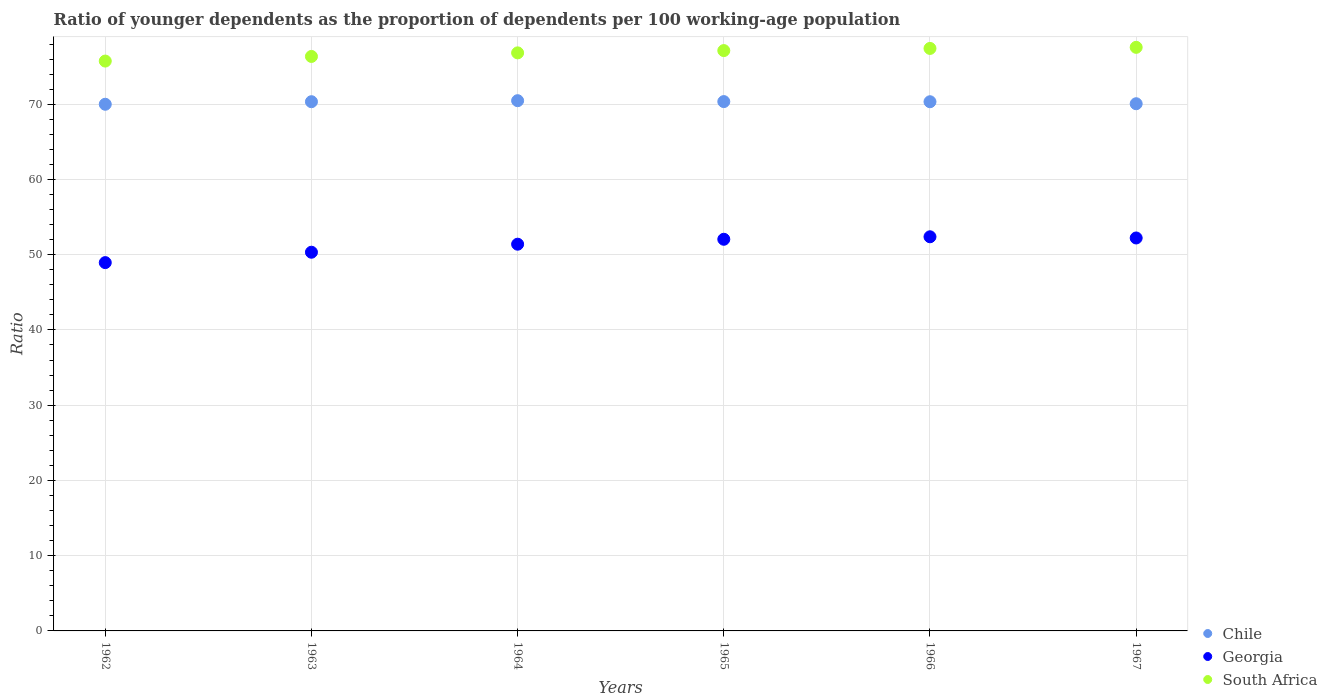Is the number of dotlines equal to the number of legend labels?
Provide a succinct answer. Yes. What is the age dependency ratio(young) in Chile in 1967?
Offer a very short reply. 70.06. Across all years, what is the maximum age dependency ratio(young) in Georgia?
Give a very brief answer. 52.38. Across all years, what is the minimum age dependency ratio(young) in South Africa?
Make the answer very short. 75.73. In which year was the age dependency ratio(young) in Georgia maximum?
Provide a short and direct response. 1966. In which year was the age dependency ratio(young) in Chile minimum?
Your answer should be very brief. 1962. What is the total age dependency ratio(young) in Georgia in the graph?
Ensure brevity in your answer.  307.33. What is the difference between the age dependency ratio(young) in South Africa in 1963 and that in 1966?
Offer a very short reply. -1.07. What is the difference between the age dependency ratio(young) in South Africa in 1963 and the age dependency ratio(young) in Georgia in 1964?
Your answer should be compact. 24.95. What is the average age dependency ratio(young) in Georgia per year?
Your answer should be very brief. 51.22. In the year 1965, what is the difference between the age dependency ratio(young) in South Africa and age dependency ratio(young) in Georgia?
Provide a succinct answer. 25.08. What is the ratio of the age dependency ratio(young) in Chile in 1962 to that in 1963?
Your answer should be very brief. 1. Is the age dependency ratio(young) in South Africa in 1962 less than that in 1964?
Your response must be concise. Yes. What is the difference between the highest and the second highest age dependency ratio(young) in South Africa?
Keep it short and to the point. 0.14. What is the difference between the highest and the lowest age dependency ratio(young) in South Africa?
Keep it short and to the point. 1.82. In how many years, is the age dependency ratio(young) in Chile greater than the average age dependency ratio(young) in Chile taken over all years?
Your answer should be compact. 4. Is it the case that in every year, the sum of the age dependency ratio(young) in Georgia and age dependency ratio(young) in South Africa  is greater than the age dependency ratio(young) in Chile?
Provide a succinct answer. Yes. Is the age dependency ratio(young) in South Africa strictly less than the age dependency ratio(young) in Georgia over the years?
Your answer should be very brief. No. How many dotlines are there?
Keep it short and to the point. 3. How many years are there in the graph?
Your response must be concise. 6. Does the graph contain any zero values?
Offer a terse response. No. Does the graph contain grids?
Provide a short and direct response. Yes. How are the legend labels stacked?
Provide a short and direct response. Vertical. What is the title of the graph?
Make the answer very short. Ratio of younger dependents as the proportion of dependents per 100 working-age population. Does "Chile" appear as one of the legend labels in the graph?
Offer a terse response. Yes. What is the label or title of the Y-axis?
Give a very brief answer. Ratio. What is the Ratio of Chile in 1962?
Offer a terse response. 69.99. What is the Ratio in Georgia in 1962?
Provide a short and direct response. 48.95. What is the Ratio of South Africa in 1962?
Offer a terse response. 75.73. What is the Ratio in Chile in 1963?
Provide a short and direct response. 70.33. What is the Ratio of Georgia in 1963?
Ensure brevity in your answer.  50.33. What is the Ratio in South Africa in 1963?
Your answer should be very brief. 76.35. What is the Ratio of Chile in 1964?
Your answer should be compact. 70.47. What is the Ratio in Georgia in 1964?
Your answer should be very brief. 51.4. What is the Ratio of South Africa in 1964?
Provide a succinct answer. 76.82. What is the Ratio of Chile in 1965?
Ensure brevity in your answer.  70.35. What is the Ratio of Georgia in 1965?
Provide a short and direct response. 52.05. What is the Ratio in South Africa in 1965?
Offer a very short reply. 77.13. What is the Ratio in Chile in 1966?
Ensure brevity in your answer.  70.33. What is the Ratio in Georgia in 1966?
Keep it short and to the point. 52.38. What is the Ratio of South Africa in 1966?
Provide a short and direct response. 77.41. What is the Ratio of Chile in 1967?
Your answer should be very brief. 70.06. What is the Ratio in Georgia in 1967?
Ensure brevity in your answer.  52.22. What is the Ratio in South Africa in 1967?
Offer a terse response. 77.56. Across all years, what is the maximum Ratio in Chile?
Your answer should be compact. 70.47. Across all years, what is the maximum Ratio of Georgia?
Your response must be concise. 52.38. Across all years, what is the maximum Ratio of South Africa?
Provide a succinct answer. 77.56. Across all years, what is the minimum Ratio of Chile?
Your response must be concise. 69.99. Across all years, what is the minimum Ratio of Georgia?
Keep it short and to the point. 48.95. Across all years, what is the minimum Ratio in South Africa?
Ensure brevity in your answer.  75.73. What is the total Ratio of Chile in the graph?
Ensure brevity in your answer.  421.53. What is the total Ratio in Georgia in the graph?
Provide a succinct answer. 307.33. What is the total Ratio of South Africa in the graph?
Provide a succinct answer. 461. What is the difference between the Ratio of Chile in 1962 and that in 1963?
Your answer should be very brief. -0.34. What is the difference between the Ratio in Georgia in 1962 and that in 1963?
Your answer should be compact. -1.38. What is the difference between the Ratio of South Africa in 1962 and that in 1963?
Offer a very short reply. -0.61. What is the difference between the Ratio of Chile in 1962 and that in 1964?
Ensure brevity in your answer.  -0.47. What is the difference between the Ratio of Georgia in 1962 and that in 1964?
Give a very brief answer. -2.45. What is the difference between the Ratio of South Africa in 1962 and that in 1964?
Provide a short and direct response. -1.09. What is the difference between the Ratio in Chile in 1962 and that in 1965?
Make the answer very short. -0.36. What is the difference between the Ratio in Georgia in 1962 and that in 1965?
Your answer should be compact. -3.1. What is the difference between the Ratio in South Africa in 1962 and that in 1965?
Provide a succinct answer. -1.39. What is the difference between the Ratio of Chile in 1962 and that in 1966?
Make the answer very short. -0.34. What is the difference between the Ratio in Georgia in 1962 and that in 1966?
Give a very brief answer. -3.43. What is the difference between the Ratio of South Africa in 1962 and that in 1966?
Your answer should be very brief. -1.68. What is the difference between the Ratio of Chile in 1962 and that in 1967?
Your answer should be compact. -0.07. What is the difference between the Ratio in Georgia in 1962 and that in 1967?
Your answer should be compact. -3.27. What is the difference between the Ratio of South Africa in 1962 and that in 1967?
Offer a very short reply. -1.82. What is the difference between the Ratio in Chile in 1963 and that in 1964?
Offer a terse response. -0.14. What is the difference between the Ratio in Georgia in 1963 and that in 1964?
Provide a short and direct response. -1.07. What is the difference between the Ratio of South Africa in 1963 and that in 1964?
Keep it short and to the point. -0.48. What is the difference between the Ratio in Chile in 1963 and that in 1965?
Offer a very short reply. -0.02. What is the difference between the Ratio in Georgia in 1963 and that in 1965?
Keep it short and to the point. -1.72. What is the difference between the Ratio in South Africa in 1963 and that in 1965?
Your response must be concise. -0.78. What is the difference between the Ratio in Chile in 1963 and that in 1966?
Give a very brief answer. 0. What is the difference between the Ratio of Georgia in 1963 and that in 1966?
Your answer should be compact. -2.05. What is the difference between the Ratio in South Africa in 1963 and that in 1966?
Give a very brief answer. -1.07. What is the difference between the Ratio in Chile in 1963 and that in 1967?
Provide a succinct answer. 0.27. What is the difference between the Ratio of Georgia in 1963 and that in 1967?
Provide a short and direct response. -1.89. What is the difference between the Ratio in South Africa in 1963 and that in 1967?
Provide a succinct answer. -1.21. What is the difference between the Ratio of Chile in 1964 and that in 1965?
Offer a terse response. 0.12. What is the difference between the Ratio of Georgia in 1964 and that in 1965?
Your answer should be compact. -0.66. What is the difference between the Ratio of South Africa in 1964 and that in 1965?
Provide a short and direct response. -0.3. What is the difference between the Ratio in Chile in 1964 and that in 1966?
Provide a short and direct response. 0.14. What is the difference between the Ratio of Georgia in 1964 and that in 1966?
Offer a very short reply. -0.99. What is the difference between the Ratio of South Africa in 1964 and that in 1966?
Your response must be concise. -0.59. What is the difference between the Ratio in Chile in 1964 and that in 1967?
Keep it short and to the point. 0.4. What is the difference between the Ratio of Georgia in 1964 and that in 1967?
Ensure brevity in your answer.  -0.83. What is the difference between the Ratio of South Africa in 1964 and that in 1967?
Your answer should be very brief. -0.73. What is the difference between the Ratio in Chile in 1965 and that in 1966?
Your answer should be compact. 0.02. What is the difference between the Ratio in Georgia in 1965 and that in 1966?
Provide a succinct answer. -0.33. What is the difference between the Ratio of South Africa in 1965 and that in 1966?
Make the answer very short. -0.29. What is the difference between the Ratio in Chile in 1965 and that in 1967?
Provide a short and direct response. 0.28. What is the difference between the Ratio of Georgia in 1965 and that in 1967?
Your answer should be very brief. -0.17. What is the difference between the Ratio in South Africa in 1965 and that in 1967?
Provide a short and direct response. -0.43. What is the difference between the Ratio in Chile in 1966 and that in 1967?
Keep it short and to the point. 0.27. What is the difference between the Ratio of Georgia in 1966 and that in 1967?
Offer a terse response. 0.16. What is the difference between the Ratio in South Africa in 1966 and that in 1967?
Provide a short and direct response. -0.14. What is the difference between the Ratio of Chile in 1962 and the Ratio of Georgia in 1963?
Provide a short and direct response. 19.66. What is the difference between the Ratio of Chile in 1962 and the Ratio of South Africa in 1963?
Your answer should be compact. -6.35. What is the difference between the Ratio of Georgia in 1962 and the Ratio of South Africa in 1963?
Your answer should be compact. -27.4. What is the difference between the Ratio of Chile in 1962 and the Ratio of Georgia in 1964?
Your response must be concise. 18.6. What is the difference between the Ratio of Chile in 1962 and the Ratio of South Africa in 1964?
Provide a succinct answer. -6.83. What is the difference between the Ratio of Georgia in 1962 and the Ratio of South Africa in 1964?
Provide a succinct answer. -27.88. What is the difference between the Ratio in Chile in 1962 and the Ratio in Georgia in 1965?
Make the answer very short. 17.94. What is the difference between the Ratio of Chile in 1962 and the Ratio of South Africa in 1965?
Keep it short and to the point. -7.13. What is the difference between the Ratio of Georgia in 1962 and the Ratio of South Africa in 1965?
Offer a very short reply. -28.18. What is the difference between the Ratio in Chile in 1962 and the Ratio in Georgia in 1966?
Provide a succinct answer. 17.61. What is the difference between the Ratio in Chile in 1962 and the Ratio in South Africa in 1966?
Provide a succinct answer. -7.42. What is the difference between the Ratio of Georgia in 1962 and the Ratio of South Africa in 1966?
Offer a terse response. -28.46. What is the difference between the Ratio in Chile in 1962 and the Ratio in Georgia in 1967?
Your response must be concise. 17.77. What is the difference between the Ratio in Chile in 1962 and the Ratio in South Africa in 1967?
Make the answer very short. -7.57. What is the difference between the Ratio in Georgia in 1962 and the Ratio in South Africa in 1967?
Offer a very short reply. -28.61. What is the difference between the Ratio of Chile in 1963 and the Ratio of Georgia in 1964?
Offer a very short reply. 18.94. What is the difference between the Ratio of Chile in 1963 and the Ratio of South Africa in 1964?
Provide a short and direct response. -6.49. What is the difference between the Ratio in Georgia in 1963 and the Ratio in South Africa in 1964?
Give a very brief answer. -26.5. What is the difference between the Ratio of Chile in 1963 and the Ratio of Georgia in 1965?
Offer a terse response. 18.28. What is the difference between the Ratio of Chile in 1963 and the Ratio of South Africa in 1965?
Give a very brief answer. -6.79. What is the difference between the Ratio in Georgia in 1963 and the Ratio in South Africa in 1965?
Make the answer very short. -26.8. What is the difference between the Ratio in Chile in 1963 and the Ratio in Georgia in 1966?
Provide a short and direct response. 17.95. What is the difference between the Ratio in Chile in 1963 and the Ratio in South Africa in 1966?
Make the answer very short. -7.08. What is the difference between the Ratio of Georgia in 1963 and the Ratio of South Africa in 1966?
Make the answer very short. -27.08. What is the difference between the Ratio of Chile in 1963 and the Ratio of Georgia in 1967?
Your response must be concise. 18.11. What is the difference between the Ratio of Chile in 1963 and the Ratio of South Africa in 1967?
Provide a succinct answer. -7.23. What is the difference between the Ratio in Georgia in 1963 and the Ratio in South Africa in 1967?
Give a very brief answer. -27.23. What is the difference between the Ratio in Chile in 1964 and the Ratio in Georgia in 1965?
Your answer should be very brief. 18.42. What is the difference between the Ratio in Chile in 1964 and the Ratio in South Africa in 1965?
Give a very brief answer. -6.66. What is the difference between the Ratio of Georgia in 1964 and the Ratio of South Africa in 1965?
Your response must be concise. -25.73. What is the difference between the Ratio of Chile in 1964 and the Ratio of Georgia in 1966?
Your answer should be compact. 18.09. What is the difference between the Ratio of Chile in 1964 and the Ratio of South Africa in 1966?
Provide a succinct answer. -6.95. What is the difference between the Ratio in Georgia in 1964 and the Ratio in South Africa in 1966?
Provide a short and direct response. -26.02. What is the difference between the Ratio in Chile in 1964 and the Ratio in Georgia in 1967?
Make the answer very short. 18.25. What is the difference between the Ratio in Chile in 1964 and the Ratio in South Africa in 1967?
Offer a terse response. -7.09. What is the difference between the Ratio in Georgia in 1964 and the Ratio in South Africa in 1967?
Make the answer very short. -26.16. What is the difference between the Ratio in Chile in 1965 and the Ratio in Georgia in 1966?
Offer a very short reply. 17.97. What is the difference between the Ratio in Chile in 1965 and the Ratio in South Africa in 1966?
Ensure brevity in your answer.  -7.07. What is the difference between the Ratio in Georgia in 1965 and the Ratio in South Africa in 1966?
Give a very brief answer. -25.36. What is the difference between the Ratio in Chile in 1965 and the Ratio in Georgia in 1967?
Provide a short and direct response. 18.13. What is the difference between the Ratio of Chile in 1965 and the Ratio of South Africa in 1967?
Keep it short and to the point. -7.21. What is the difference between the Ratio in Georgia in 1965 and the Ratio in South Africa in 1967?
Your answer should be very brief. -25.51. What is the difference between the Ratio of Chile in 1966 and the Ratio of Georgia in 1967?
Ensure brevity in your answer.  18.11. What is the difference between the Ratio in Chile in 1966 and the Ratio in South Africa in 1967?
Offer a terse response. -7.23. What is the difference between the Ratio in Georgia in 1966 and the Ratio in South Africa in 1967?
Provide a succinct answer. -25.18. What is the average Ratio of Chile per year?
Make the answer very short. 70.26. What is the average Ratio of Georgia per year?
Your answer should be very brief. 51.22. What is the average Ratio of South Africa per year?
Provide a short and direct response. 76.83. In the year 1962, what is the difference between the Ratio in Chile and Ratio in Georgia?
Keep it short and to the point. 21.04. In the year 1962, what is the difference between the Ratio in Chile and Ratio in South Africa?
Your answer should be very brief. -5.74. In the year 1962, what is the difference between the Ratio in Georgia and Ratio in South Africa?
Keep it short and to the point. -26.79. In the year 1963, what is the difference between the Ratio in Chile and Ratio in Georgia?
Your answer should be compact. 20. In the year 1963, what is the difference between the Ratio in Chile and Ratio in South Africa?
Keep it short and to the point. -6.02. In the year 1963, what is the difference between the Ratio of Georgia and Ratio of South Africa?
Your answer should be very brief. -26.02. In the year 1964, what is the difference between the Ratio of Chile and Ratio of Georgia?
Ensure brevity in your answer.  19.07. In the year 1964, what is the difference between the Ratio of Chile and Ratio of South Africa?
Ensure brevity in your answer.  -6.36. In the year 1964, what is the difference between the Ratio in Georgia and Ratio in South Africa?
Your response must be concise. -25.43. In the year 1965, what is the difference between the Ratio in Chile and Ratio in Georgia?
Make the answer very short. 18.3. In the year 1965, what is the difference between the Ratio of Chile and Ratio of South Africa?
Keep it short and to the point. -6.78. In the year 1965, what is the difference between the Ratio in Georgia and Ratio in South Africa?
Your response must be concise. -25.08. In the year 1966, what is the difference between the Ratio of Chile and Ratio of Georgia?
Offer a terse response. 17.95. In the year 1966, what is the difference between the Ratio in Chile and Ratio in South Africa?
Your answer should be compact. -7.08. In the year 1966, what is the difference between the Ratio in Georgia and Ratio in South Africa?
Make the answer very short. -25.03. In the year 1967, what is the difference between the Ratio in Chile and Ratio in Georgia?
Your answer should be very brief. 17.84. In the year 1967, what is the difference between the Ratio in Chile and Ratio in South Africa?
Provide a short and direct response. -7.49. In the year 1967, what is the difference between the Ratio of Georgia and Ratio of South Africa?
Offer a terse response. -25.34. What is the ratio of the Ratio of Georgia in 1962 to that in 1963?
Provide a succinct answer. 0.97. What is the ratio of the Ratio of Chile in 1962 to that in 1964?
Give a very brief answer. 0.99. What is the ratio of the Ratio of Georgia in 1962 to that in 1964?
Ensure brevity in your answer.  0.95. What is the ratio of the Ratio of South Africa in 1962 to that in 1964?
Offer a very short reply. 0.99. What is the ratio of the Ratio of Chile in 1962 to that in 1965?
Keep it short and to the point. 0.99. What is the ratio of the Ratio in Georgia in 1962 to that in 1965?
Keep it short and to the point. 0.94. What is the ratio of the Ratio in South Africa in 1962 to that in 1965?
Your response must be concise. 0.98. What is the ratio of the Ratio of Georgia in 1962 to that in 1966?
Provide a short and direct response. 0.93. What is the ratio of the Ratio in South Africa in 1962 to that in 1966?
Your answer should be very brief. 0.98. What is the ratio of the Ratio in Georgia in 1962 to that in 1967?
Give a very brief answer. 0.94. What is the ratio of the Ratio of South Africa in 1962 to that in 1967?
Offer a terse response. 0.98. What is the ratio of the Ratio in Georgia in 1963 to that in 1964?
Keep it short and to the point. 0.98. What is the ratio of the Ratio of South Africa in 1963 to that in 1964?
Your answer should be very brief. 0.99. What is the ratio of the Ratio of Georgia in 1963 to that in 1965?
Your answer should be compact. 0.97. What is the ratio of the Ratio of Georgia in 1963 to that in 1966?
Offer a very short reply. 0.96. What is the ratio of the Ratio of South Africa in 1963 to that in 1966?
Provide a succinct answer. 0.99. What is the ratio of the Ratio of Chile in 1963 to that in 1967?
Provide a succinct answer. 1. What is the ratio of the Ratio of Georgia in 1963 to that in 1967?
Provide a succinct answer. 0.96. What is the ratio of the Ratio in South Africa in 1963 to that in 1967?
Ensure brevity in your answer.  0.98. What is the ratio of the Ratio of Chile in 1964 to that in 1965?
Provide a succinct answer. 1. What is the ratio of the Ratio of Georgia in 1964 to that in 1965?
Offer a very short reply. 0.99. What is the ratio of the Ratio of Chile in 1964 to that in 1966?
Offer a terse response. 1. What is the ratio of the Ratio of Georgia in 1964 to that in 1966?
Ensure brevity in your answer.  0.98. What is the ratio of the Ratio of Chile in 1964 to that in 1967?
Your answer should be compact. 1.01. What is the ratio of the Ratio of Georgia in 1964 to that in 1967?
Provide a succinct answer. 0.98. What is the ratio of the Ratio in Chile in 1965 to that in 1966?
Offer a terse response. 1. What is the ratio of the Ratio of Georgia in 1965 to that in 1966?
Offer a terse response. 0.99. What is the ratio of the Ratio of South Africa in 1965 to that in 1966?
Provide a short and direct response. 1. What is the ratio of the Ratio of Georgia in 1965 to that in 1967?
Give a very brief answer. 1. What is the ratio of the Ratio in South Africa in 1965 to that in 1967?
Offer a terse response. 0.99. What is the ratio of the Ratio of Georgia in 1966 to that in 1967?
Ensure brevity in your answer.  1. What is the difference between the highest and the second highest Ratio in Chile?
Your answer should be compact. 0.12. What is the difference between the highest and the second highest Ratio of Georgia?
Your answer should be compact. 0.16. What is the difference between the highest and the second highest Ratio in South Africa?
Your answer should be compact. 0.14. What is the difference between the highest and the lowest Ratio of Chile?
Make the answer very short. 0.47. What is the difference between the highest and the lowest Ratio in Georgia?
Give a very brief answer. 3.43. What is the difference between the highest and the lowest Ratio in South Africa?
Provide a succinct answer. 1.82. 